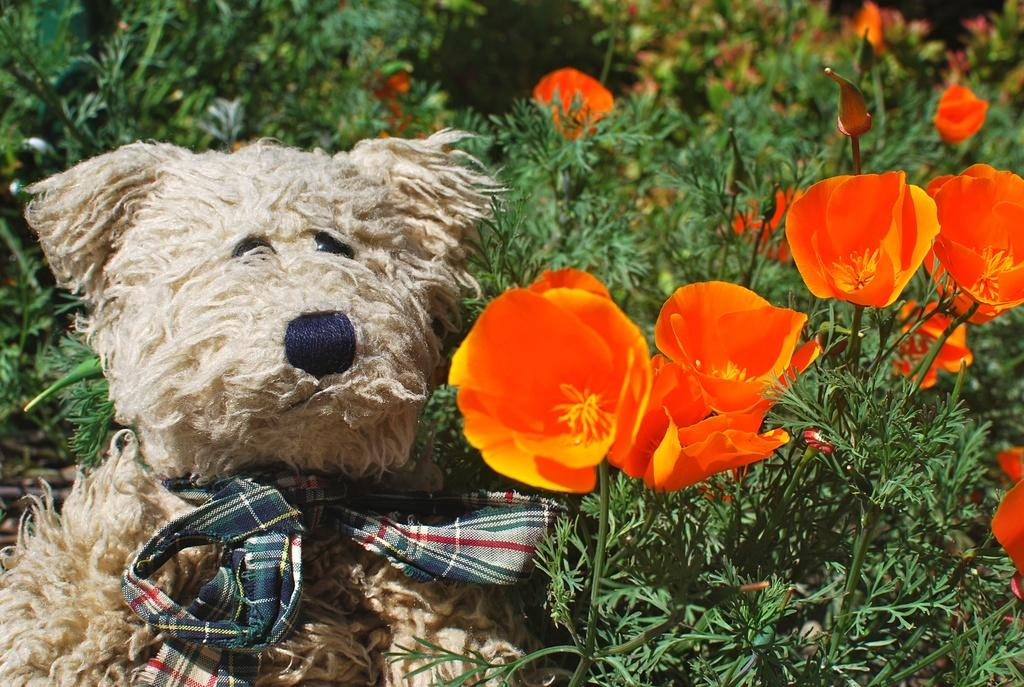What is located on the left side of the image? There is a teddy bear on the left side of the image. What can be seen on the right side of the image? There are flower plants on the right side of the image. What type of pipe is visible in the image? There is no pipe present in the image. Are there any dinosaurs visible in the image? There are no dinosaurs present in the image. 